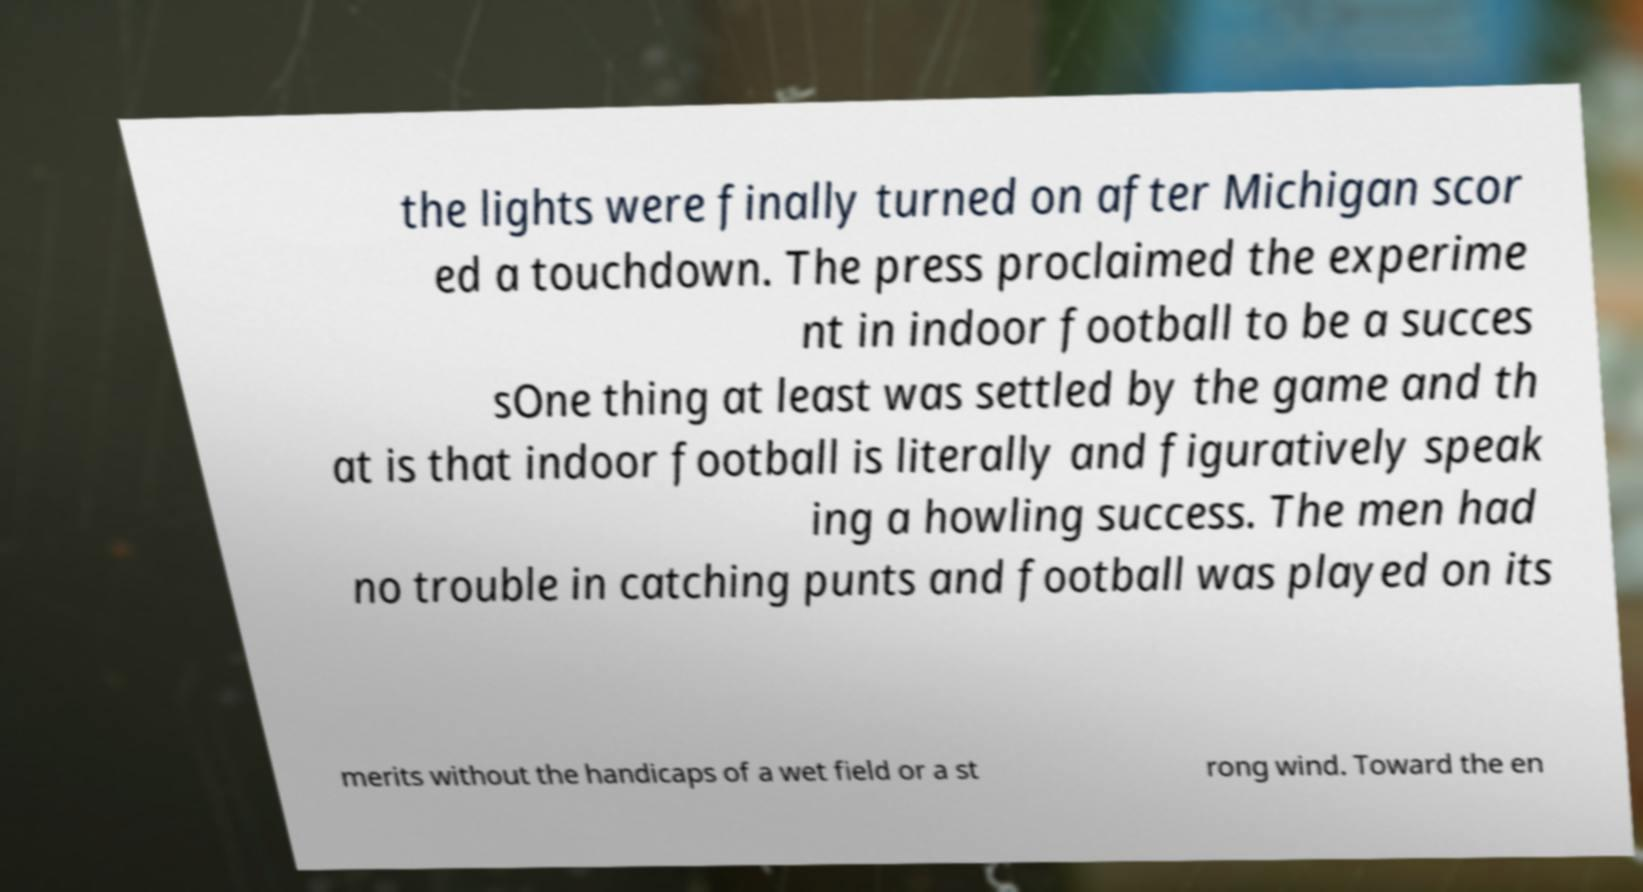Could you assist in decoding the text presented in this image and type it out clearly? the lights were finally turned on after Michigan scor ed a touchdown. The press proclaimed the experime nt in indoor football to be a succes sOne thing at least was settled by the game and th at is that indoor football is literally and figuratively speak ing a howling success. The men had no trouble in catching punts and football was played on its merits without the handicaps of a wet field or a st rong wind. Toward the en 